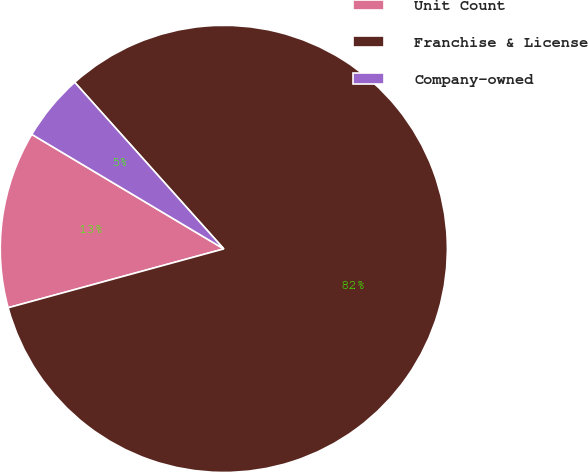Convert chart. <chart><loc_0><loc_0><loc_500><loc_500><pie_chart><fcel>Unit Count<fcel>Franchise & License<fcel>Company-owned<nl><fcel>12.8%<fcel>82.38%<fcel>4.82%<nl></chart> 